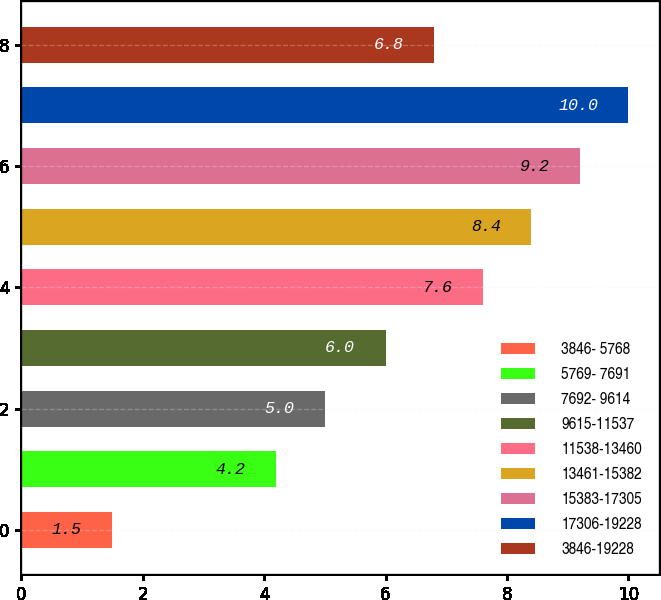Convert chart to OTSL. <chart><loc_0><loc_0><loc_500><loc_500><bar_chart><fcel>3846- 5768<fcel>5769- 7691<fcel>7692- 9614<fcel>9615-11537<fcel>11538-13460<fcel>13461-15382<fcel>15383-17305<fcel>17306-19228<fcel>3846-19228<nl><fcel>1.5<fcel>4.2<fcel>5<fcel>6<fcel>7.6<fcel>8.4<fcel>9.2<fcel>10<fcel>6.8<nl></chart> 